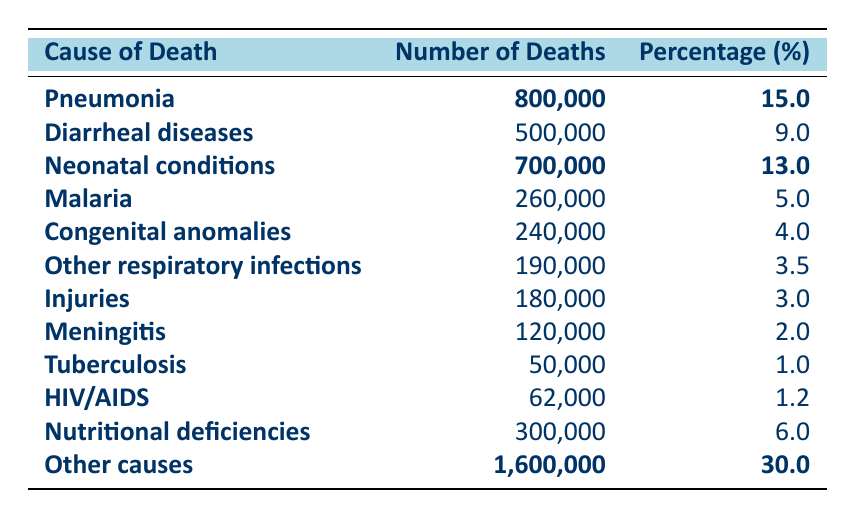What's the leading cause of death among children under five? The table shows that Pneumonia has the highest number of deaths at 800,000, which is also indicated with bold text.
Answer: Pneumonia How many deaths were attributed to Neonatal conditions? The table lists Neonatal conditions with a bolded value of 700,000 deaths.
Answer: 700,000 What percentage of deaths were caused by Diarrheal diseases? The table shows that Diarrheal diseases account for 9% of deaths among children under five, which is not bolded.
Answer: 9% What is the total number of deaths from Malaria and Tuberculosis combined? Malaria has 260,000 deaths and Tuberculosis has 50,000 deaths. Summing these gives 260,000 + 50,000 = 310,000 deaths.
Answer: 310,000 Which cause of death has the lowest percentage among children under five? The table indicates that Tuberculosis has the lowest percentage of 1%, as shown in the data.
Answer: Tuberculosis How many deaths are attributed to Other causes, and what percentage does it represent? Other causes are noted with a bold value of 1,600,000 deaths, which accounts for 30% of the total.
Answer: 1,600,000 deaths, 30% What is the average number of deaths from the top three causes listed? The top three causes with deaths are Pneumonia (800,000), Neonatal conditions (700,000), and Diarrheal diseases (500,000). Summing these gives 800,000 + 700,000 + 500,000 = 2,000,000. The average is 2,000,000 divided by 3, which equals 666,666.67.
Answer: 666,666.67 Is the percentage of deaths from Nutritional deficiencies greater than that of Malaria? Nutritional deficiencies account for 6% while Malaria accounts for 5%. Since 6% is greater than 5%, the statement is true.
Answer: Yes What proportion of total deaths does Injuries account for among the listed causes? Injuries lead to 180,000 deaths. The total deaths in the table is 5,333,000 (adding all causes), so the proportion is calculated as (180,000 / 5,333,000) * 100 = approximately 3.37%.
Answer: Approximately 3.37% 